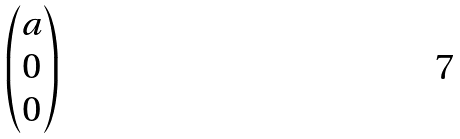<formula> <loc_0><loc_0><loc_500><loc_500>\begin{pmatrix} a \\ 0 \\ 0 \end{pmatrix}</formula> 